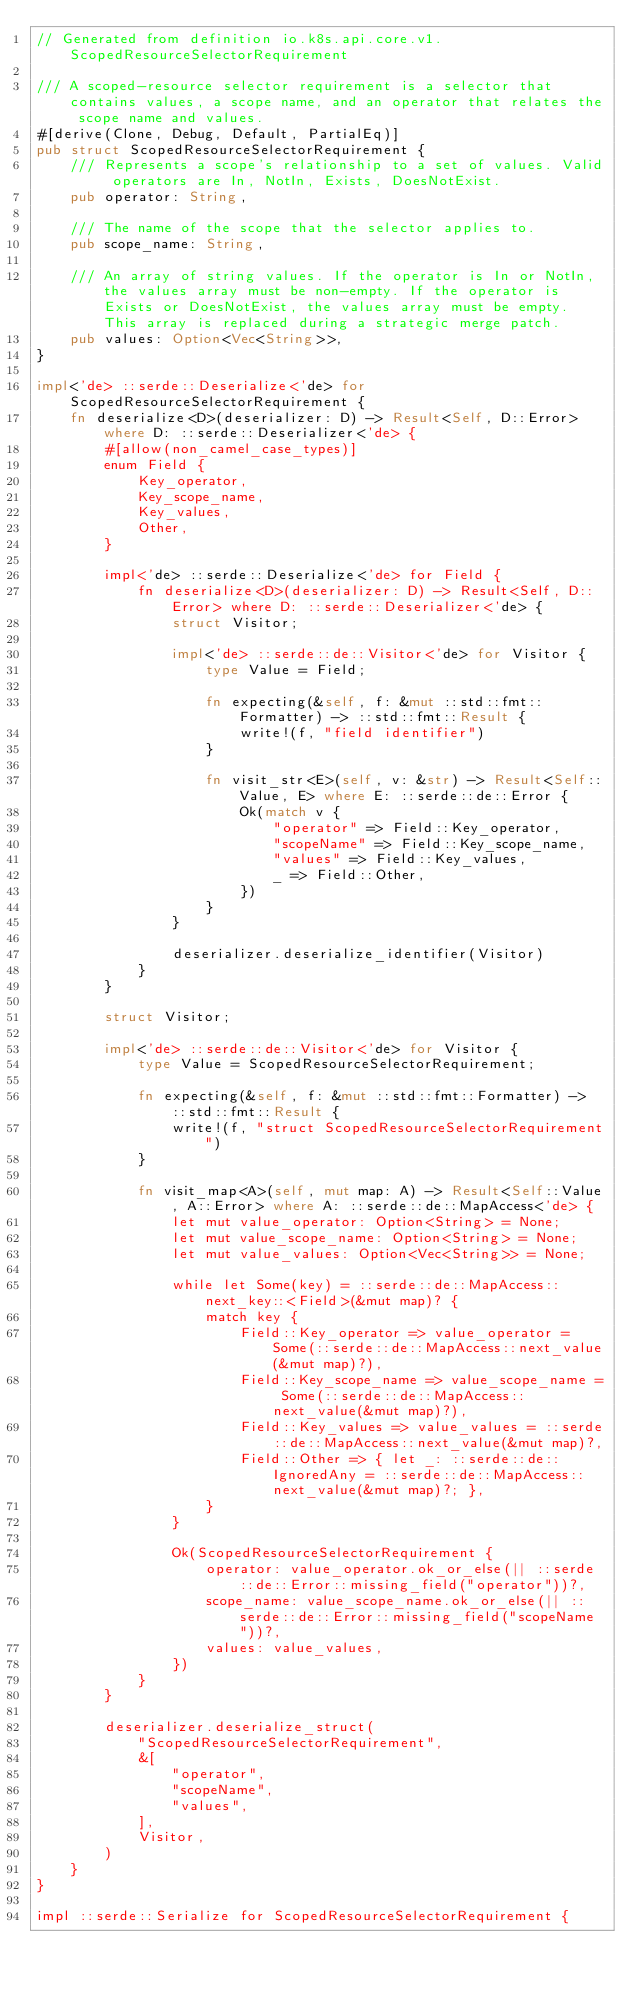<code> <loc_0><loc_0><loc_500><loc_500><_Rust_>// Generated from definition io.k8s.api.core.v1.ScopedResourceSelectorRequirement

/// A scoped-resource selector requirement is a selector that contains values, a scope name, and an operator that relates the scope name and values.
#[derive(Clone, Debug, Default, PartialEq)]
pub struct ScopedResourceSelectorRequirement {
    /// Represents a scope's relationship to a set of values. Valid operators are In, NotIn, Exists, DoesNotExist.
    pub operator: String,

    /// The name of the scope that the selector applies to.
    pub scope_name: String,

    /// An array of string values. If the operator is In or NotIn, the values array must be non-empty. If the operator is Exists or DoesNotExist, the values array must be empty. This array is replaced during a strategic merge patch.
    pub values: Option<Vec<String>>,
}

impl<'de> ::serde::Deserialize<'de> for ScopedResourceSelectorRequirement {
    fn deserialize<D>(deserializer: D) -> Result<Self, D::Error> where D: ::serde::Deserializer<'de> {
        #[allow(non_camel_case_types)]
        enum Field {
            Key_operator,
            Key_scope_name,
            Key_values,
            Other,
        }

        impl<'de> ::serde::Deserialize<'de> for Field {
            fn deserialize<D>(deserializer: D) -> Result<Self, D::Error> where D: ::serde::Deserializer<'de> {
                struct Visitor;

                impl<'de> ::serde::de::Visitor<'de> for Visitor {
                    type Value = Field;

                    fn expecting(&self, f: &mut ::std::fmt::Formatter) -> ::std::fmt::Result {
                        write!(f, "field identifier")
                    }

                    fn visit_str<E>(self, v: &str) -> Result<Self::Value, E> where E: ::serde::de::Error {
                        Ok(match v {
                            "operator" => Field::Key_operator,
                            "scopeName" => Field::Key_scope_name,
                            "values" => Field::Key_values,
                            _ => Field::Other,
                        })
                    }
                }

                deserializer.deserialize_identifier(Visitor)
            }
        }

        struct Visitor;

        impl<'de> ::serde::de::Visitor<'de> for Visitor {
            type Value = ScopedResourceSelectorRequirement;

            fn expecting(&self, f: &mut ::std::fmt::Formatter) -> ::std::fmt::Result {
                write!(f, "struct ScopedResourceSelectorRequirement")
            }

            fn visit_map<A>(self, mut map: A) -> Result<Self::Value, A::Error> where A: ::serde::de::MapAccess<'de> {
                let mut value_operator: Option<String> = None;
                let mut value_scope_name: Option<String> = None;
                let mut value_values: Option<Vec<String>> = None;

                while let Some(key) = ::serde::de::MapAccess::next_key::<Field>(&mut map)? {
                    match key {
                        Field::Key_operator => value_operator = Some(::serde::de::MapAccess::next_value(&mut map)?),
                        Field::Key_scope_name => value_scope_name = Some(::serde::de::MapAccess::next_value(&mut map)?),
                        Field::Key_values => value_values = ::serde::de::MapAccess::next_value(&mut map)?,
                        Field::Other => { let _: ::serde::de::IgnoredAny = ::serde::de::MapAccess::next_value(&mut map)?; },
                    }
                }

                Ok(ScopedResourceSelectorRequirement {
                    operator: value_operator.ok_or_else(|| ::serde::de::Error::missing_field("operator"))?,
                    scope_name: value_scope_name.ok_or_else(|| ::serde::de::Error::missing_field("scopeName"))?,
                    values: value_values,
                })
            }
        }

        deserializer.deserialize_struct(
            "ScopedResourceSelectorRequirement",
            &[
                "operator",
                "scopeName",
                "values",
            ],
            Visitor,
        )
    }
}

impl ::serde::Serialize for ScopedResourceSelectorRequirement {</code> 